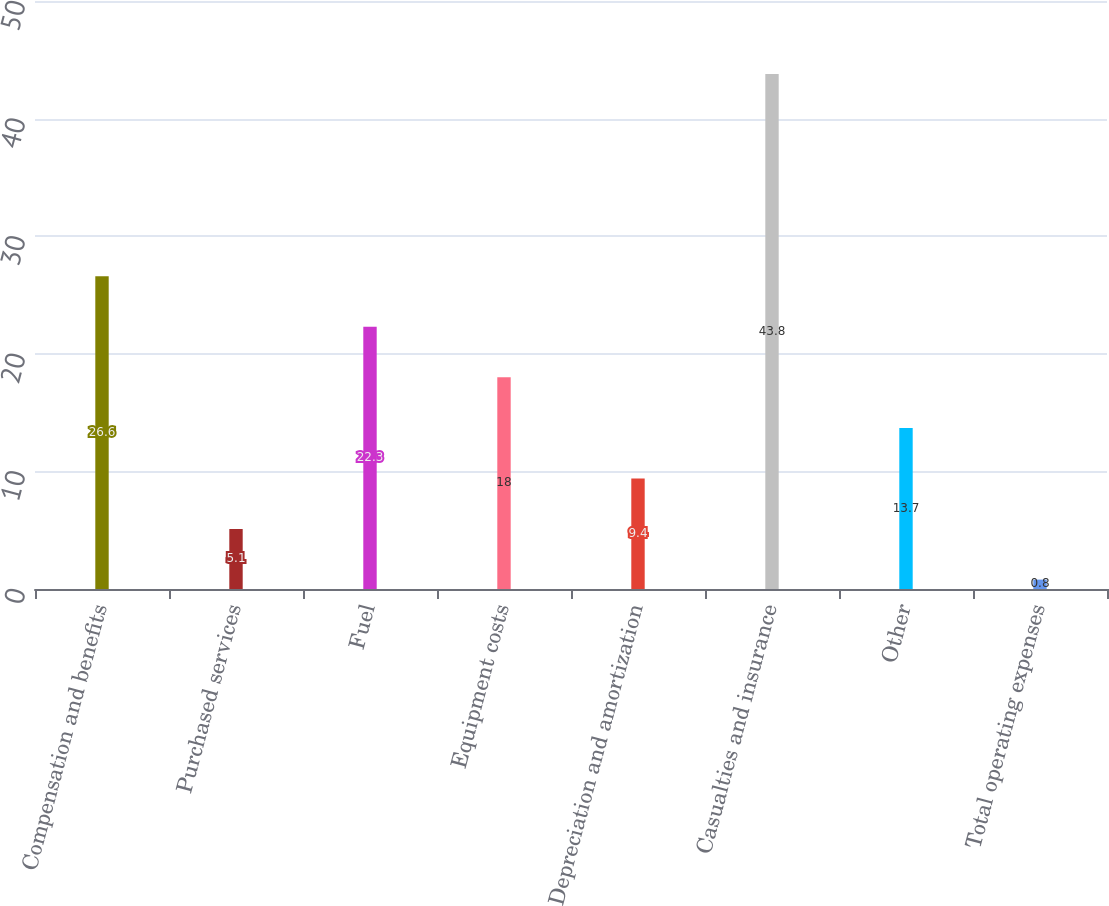<chart> <loc_0><loc_0><loc_500><loc_500><bar_chart><fcel>Compensation and benefits<fcel>Purchased services<fcel>Fuel<fcel>Equipment costs<fcel>Depreciation and amortization<fcel>Casualties and insurance<fcel>Other<fcel>Total operating expenses<nl><fcel>26.6<fcel>5.1<fcel>22.3<fcel>18<fcel>9.4<fcel>43.8<fcel>13.7<fcel>0.8<nl></chart> 